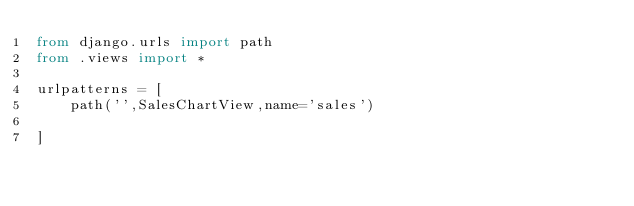Convert code to text. <code><loc_0><loc_0><loc_500><loc_500><_Python_>from django.urls import path
from .views import *

urlpatterns = [
    path('',SalesChartView,name='sales')
    
]
</code> 